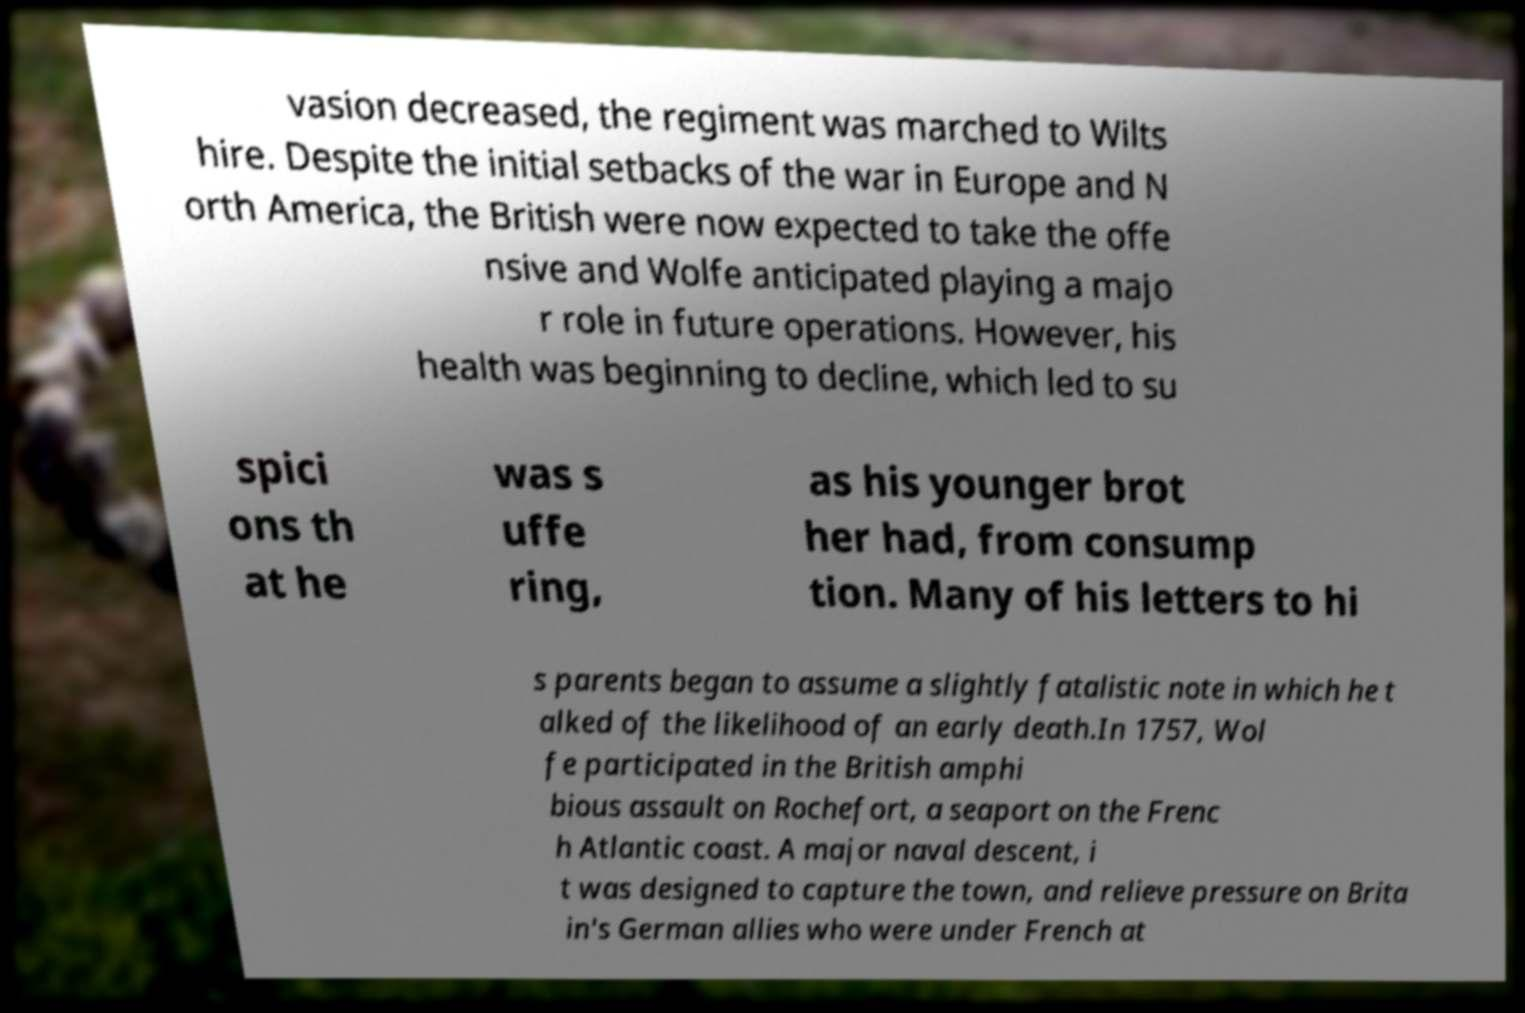For documentation purposes, I need the text within this image transcribed. Could you provide that? vasion decreased, the regiment was marched to Wilts hire. Despite the initial setbacks of the war in Europe and N orth America, the British were now expected to take the offe nsive and Wolfe anticipated playing a majo r role in future operations. However, his health was beginning to decline, which led to su spici ons th at he was s uffe ring, as his younger brot her had, from consump tion. Many of his letters to hi s parents began to assume a slightly fatalistic note in which he t alked of the likelihood of an early death.In 1757, Wol fe participated in the British amphi bious assault on Rochefort, a seaport on the Frenc h Atlantic coast. A major naval descent, i t was designed to capture the town, and relieve pressure on Brita in's German allies who were under French at 